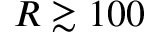Convert formula to latex. <formula><loc_0><loc_0><loc_500><loc_500>R \gtrsim 1 0 0</formula> 